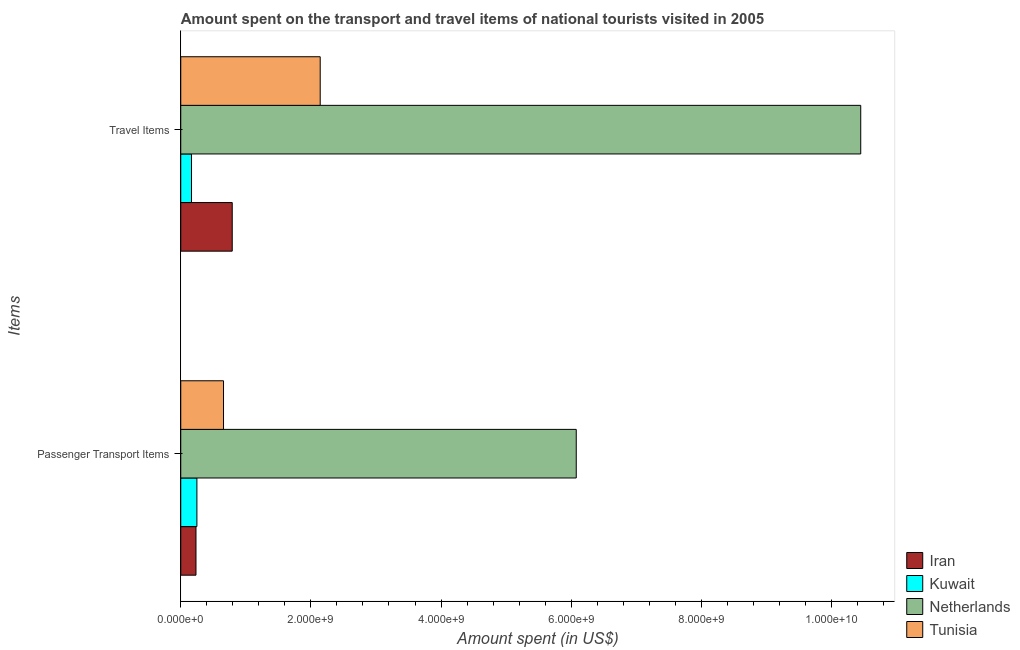How many different coloured bars are there?
Give a very brief answer. 4. How many groups of bars are there?
Provide a short and direct response. 2. Are the number of bars per tick equal to the number of legend labels?
Keep it short and to the point. Yes. What is the label of the 1st group of bars from the top?
Keep it short and to the point. Travel Items. What is the amount spent on passenger transport items in Tunisia?
Offer a very short reply. 6.57e+08. Across all countries, what is the maximum amount spent on passenger transport items?
Offer a very short reply. 6.08e+09. Across all countries, what is the minimum amount spent in travel items?
Keep it short and to the point. 1.65e+08. In which country was the amount spent in travel items minimum?
Offer a very short reply. Kuwait. What is the total amount spent on passenger transport items in the graph?
Your answer should be very brief. 7.22e+09. What is the difference between the amount spent on passenger transport items in Tunisia and that in Iran?
Your answer should be very brief. 4.23e+08. What is the difference between the amount spent in travel items in Netherlands and the amount spent on passenger transport items in Tunisia?
Offer a very short reply. 9.79e+09. What is the average amount spent in travel items per country?
Give a very brief answer. 3.39e+09. What is the difference between the amount spent on passenger transport items and amount spent in travel items in Tunisia?
Provide a succinct answer. -1.49e+09. What is the ratio of the amount spent in travel items in Iran to that in Tunisia?
Keep it short and to the point. 0.37. Is the amount spent in travel items in Tunisia less than that in Kuwait?
Give a very brief answer. No. In how many countries, is the amount spent in travel items greater than the average amount spent in travel items taken over all countries?
Ensure brevity in your answer.  1. What does the 2nd bar from the top in Travel Items represents?
Ensure brevity in your answer.  Netherlands. What does the 2nd bar from the bottom in Passenger Transport Items represents?
Provide a succinct answer. Kuwait. Are all the bars in the graph horizontal?
Offer a terse response. Yes. How many countries are there in the graph?
Offer a terse response. 4. What is the difference between two consecutive major ticks on the X-axis?
Provide a short and direct response. 2.00e+09. Does the graph contain grids?
Keep it short and to the point. No. Where does the legend appear in the graph?
Provide a short and direct response. Bottom right. How many legend labels are there?
Your answer should be very brief. 4. What is the title of the graph?
Keep it short and to the point. Amount spent on the transport and travel items of national tourists visited in 2005. What is the label or title of the X-axis?
Your answer should be very brief. Amount spent (in US$). What is the label or title of the Y-axis?
Offer a very short reply. Items. What is the Amount spent (in US$) in Iran in Passenger Transport Items?
Your response must be concise. 2.34e+08. What is the Amount spent (in US$) of Kuwait in Passenger Transport Items?
Offer a terse response. 2.48e+08. What is the Amount spent (in US$) in Netherlands in Passenger Transport Items?
Give a very brief answer. 6.08e+09. What is the Amount spent (in US$) of Tunisia in Passenger Transport Items?
Give a very brief answer. 6.57e+08. What is the Amount spent (in US$) in Iran in Travel Items?
Your response must be concise. 7.91e+08. What is the Amount spent (in US$) in Kuwait in Travel Items?
Your answer should be very brief. 1.65e+08. What is the Amount spent (in US$) of Netherlands in Travel Items?
Your response must be concise. 1.04e+1. What is the Amount spent (in US$) of Tunisia in Travel Items?
Keep it short and to the point. 2.14e+09. Across all Items, what is the maximum Amount spent (in US$) in Iran?
Provide a short and direct response. 7.91e+08. Across all Items, what is the maximum Amount spent (in US$) in Kuwait?
Provide a succinct answer. 2.48e+08. Across all Items, what is the maximum Amount spent (in US$) of Netherlands?
Your answer should be compact. 1.04e+1. Across all Items, what is the maximum Amount spent (in US$) of Tunisia?
Make the answer very short. 2.14e+09. Across all Items, what is the minimum Amount spent (in US$) in Iran?
Offer a very short reply. 2.34e+08. Across all Items, what is the minimum Amount spent (in US$) of Kuwait?
Your answer should be compact. 1.65e+08. Across all Items, what is the minimum Amount spent (in US$) in Netherlands?
Ensure brevity in your answer.  6.08e+09. Across all Items, what is the minimum Amount spent (in US$) in Tunisia?
Make the answer very short. 6.57e+08. What is the total Amount spent (in US$) of Iran in the graph?
Ensure brevity in your answer.  1.02e+09. What is the total Amount spent (in US$) in Kuwait in the graph?
Provide a short and direct response. 4.13e+08. What is the total Amount spent (in US$) of Netherlands in the graph?
Provide a succinct answer. 1.65e+1. What is the total Amount spent (in US$) of Tunisia in the graph?
Provide a short and direct response. 2.80e+09. What is the difference between the Amount spent (in US$) in Iran in Passenger Transport Items and that in Travel Items?
Your response must be concise. -5.57e+08. What is the difference between the Amount spent (in US$) in Kuwait in Passenger Transport Items and that in Travel Items?
Make the answer very short. 8.30e+07. What is the difference between the Amount spent (in US$) in Netherlands in Passenger Transport Items and that in Travel Items?
Provide a succinct answer. -4.37e+09. What is the difference between the Amount spent (in US$) in Tunisia in Passenger Transport Items and that in Travel Items?
Offer a very short reply. -1.49e+09. What is the difference between the Amount spent (in US$) of Iran in Passenger Transport Items and the Amount spent (in US$) of Kuwait in Travel Items?
Give a very brief answer. 6.90e+07. What is the difference between the Amount spent (in US$) in Iran in Passenger Transport Items and the Amount spent (in US$) in Netherlands in Travel Items?
Make the answer very short. -1.02e+1. What is the difference between the Amount spent (in US$) of Iran in Passenger Transport Items and the Amount spent (in US$) of Tunisia in Travel Items?
Provide a succinct answer. -1.91e+09. What is the difference between the Amount spent (in US$) in Kuwait in Passenger Transport Items and the Amount spent (in US$) in Netherlands in Travel Items?
Your answer should be compact. -1.02e+1. What is the difference between the Amount spent (in US$) in Kuwait in Passenger Transport Items and the Amount spent (in US$) in Tunisia in Travel Items?
Offer a very short reply. -1.90e+09. What is the difference between the Amount spent (in US$) of Netherlands in Passenger Transport Items and the Amount spent (in US$) of Tunisia in Travel Items?
Provide a short and direct response. 3.94e+09. What is the average Amount spent (in US$) in Iran per Items?
Your response must be concise. 5.12e+08. What is the average Amount spent (in US$) of Kuwait per Items?
Your response must be concise. 2.06e+08. What is the average Amount spent (in US$) in Netherlands per Items?
Your answer should be very brief. 8.26e+09. What is the average Amount spent (in US$) of Tunisia per Items?
Your answer should be compact. 1.40e+09. What is the difference between the Amount spent (in US$) in Iran and Amount spent (in US$) in Kuwait in Passenger Transport Items?
Your answer should be very brief. -1.40e+07. What is the difference between the Amount spent (in US$) in Iran and Amount spent (in US$) in Netherlands in Passenger Transport Items?
Ensure brevity in your answer.  -5.84e+09. What is the difference between the Amount spent (in US$) of Iran and Amount spent (in US$) of Tunisia in Passenger Transport Items?
Your answer should be very brief. -4.23e+08. What is the difference between the Amount spent (in US$) of Kuwait and Amount spent (in US$) of Netherlands in Passenger Transport Items?
Provide a short and direct response. -5.83e+09. What is the difference between the Amount spent (in US$) in Kuwait and Amount spent (in US$) in Tunisia in Passenger Transport Items?
Make the answer very short. -4.09e+08. What is the difference between the Amount spent (in US$) in Netherlands and Amount spent (in US$) in Tunisia in Passenger Transport Items?
Ensure brevity in your answer.  5.42e+09. What is the difference between the Amount spent (in US$) in Iran and Amount spent (in US$) in Kuwait in Travel Items?
Give a very brief answer. 6.26e+08. What is the difference between the Amount spent (in US$) of Iran and Amount spent (in US$) of Netherlands in Travel Items?
Provide a short and direct response. -9.66e+09. What is the difference between the Amount spent (in US$) of Iran and Amount spent (in US$) of Tunisia in Travel Items?
Your response must be concise. -1.35e+09. What is the difference between the Amount spent (in US$) of Kuwait and Amount spent (in US$) of Netherlands in Travel Items?
Give a very brief answer. -1.03e+1. What is the difference between the Amount spent (in US$) in Kuwait and Amount spent (in US$) in Tunisia in Travel Items?
Offer a terse response. -1.98e+09. What is the difference between the Amount spent (in US$) in Netherlands and Amount spent (in US$) in Tunisia in Travel Items?
Your answer should be very brief. 8.31e+09. What is the ratio of the Amount spent (in US$) in Iran in Passenger Transport Items to that in Travel Items?
Your response must be concise. 0.3. What is the ratio of the Amount spent (in US$) in Kuwait in Passenger Transport Items to that in Travel Items?
Ensure brevity in your answer.  1.5. What is the ratio of the Amount spent (in US$) in Netherlands in Passenger Transport Items to that in Travel Items?
Give a very brief answer. 0.58. What is the ratio of the Amount spent (in US$) of Tunisia in Passenger Transport Items to that in Travel Items?
Offer a very short reply. 0.31. What is the difference between the highest and the second highest Amount spent (in US$) of Iran?
Provide a short and direct response. 5.57e+08. What is the difference between the highest and the second highest Amount spent (in US$) of Kuwait?
Make the answer very short. 8.30e+07. What is the difference between the highest and the second highest Amount spent (in US$) in Netherlands?
Provide a short and direct response. 4.37e+09. What is the difference between the highest and the second highest Amount spent (in US$) of Tunisia?
Provide a short and direct response. 1.49e+09. What is the difference between the highest and the lowest Amount spent (in US$) of Iran?
Your answer should be compact. 5.57e+08. What is the difference between the highest and the lowest Amount spent (in US$) in Kuwait?
Make the answer very short. 8.30e+07. What is the difference between the highest and the lowest Amount spent (in US$) in Netherlands?
Your response must be concise. 4.37e+09. What is the difference between the highest and the lowest Amount spent (in US$) in Tunisia?
Make the answer very short. 1.49e+09. 